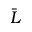Convert formula to latex. <formula><loc_0><loc_0><loc_500><loc_500>\bar { L }</formula> 